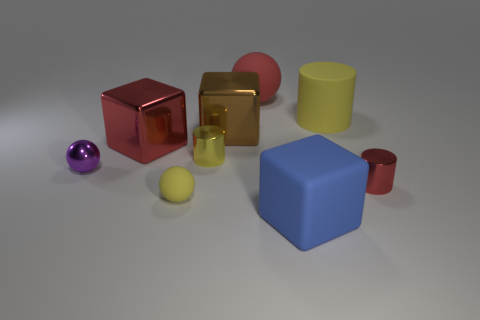What is the size of the red metal thing that is left of the blue rubber object that is right of the big red rubber ball?
Your response must be concise. Large. What is the material of the other tiny thing that is the same shape as the yellow metal object?
Provide a short and direct response. Metal. What number of tiny red balls are there?
Make the answer very short. 0. The small metal cylinder that is to the left of the yellow object to the right of the sphere behind the large cylinder is what color?
Give a very brief answer. Yellow. Is the number of tiny cylinders less than the number of small rubber things?
Offer a terse response. No. What is the color of the other tiny thing that is the same shape as the small purple object?
Offer a very short reply. Yellow. There is a block that is the same material as the small yellow ball; what is its color?
Ensure brevity in your answer.  Blue. How many brown metal objects have the same size as the red metal block?
Ensure brevity in your answer.  1. What material is the big blue block?
Your response must be concise. Rubber. Are there more shiny cylinders than yellow things?
Your answer should be very brief. No. 